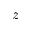<formula> <loc_0><loc_0><loc_500><loc_500>z</formula> 